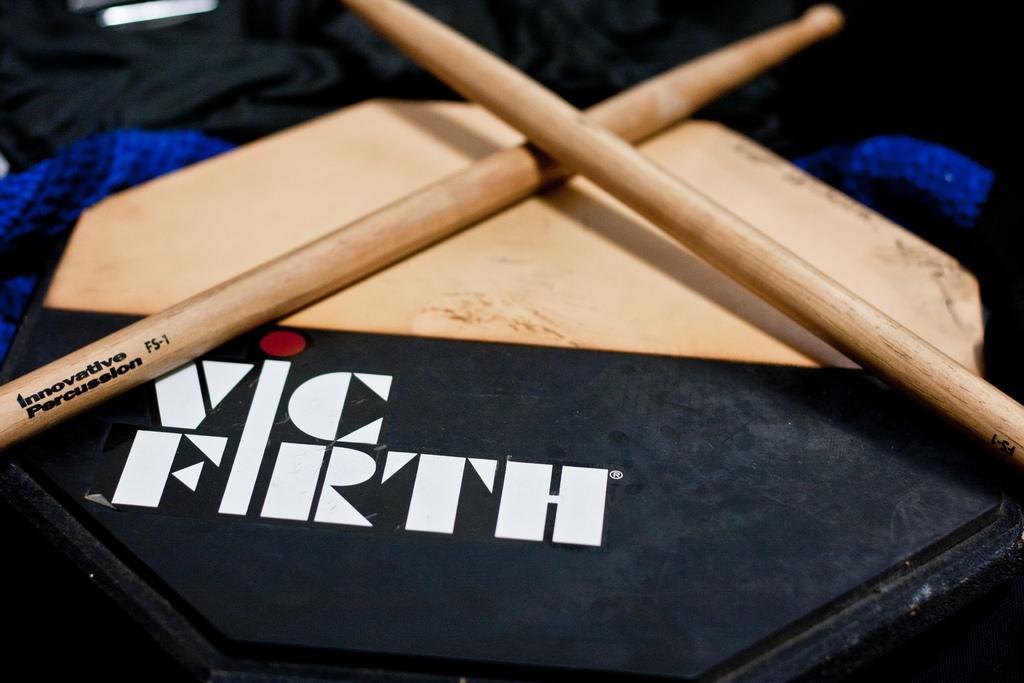Describe this image in one or two sentences. In this image I can see some wood material on which few black color clothes are placed. It is looking like a box. 